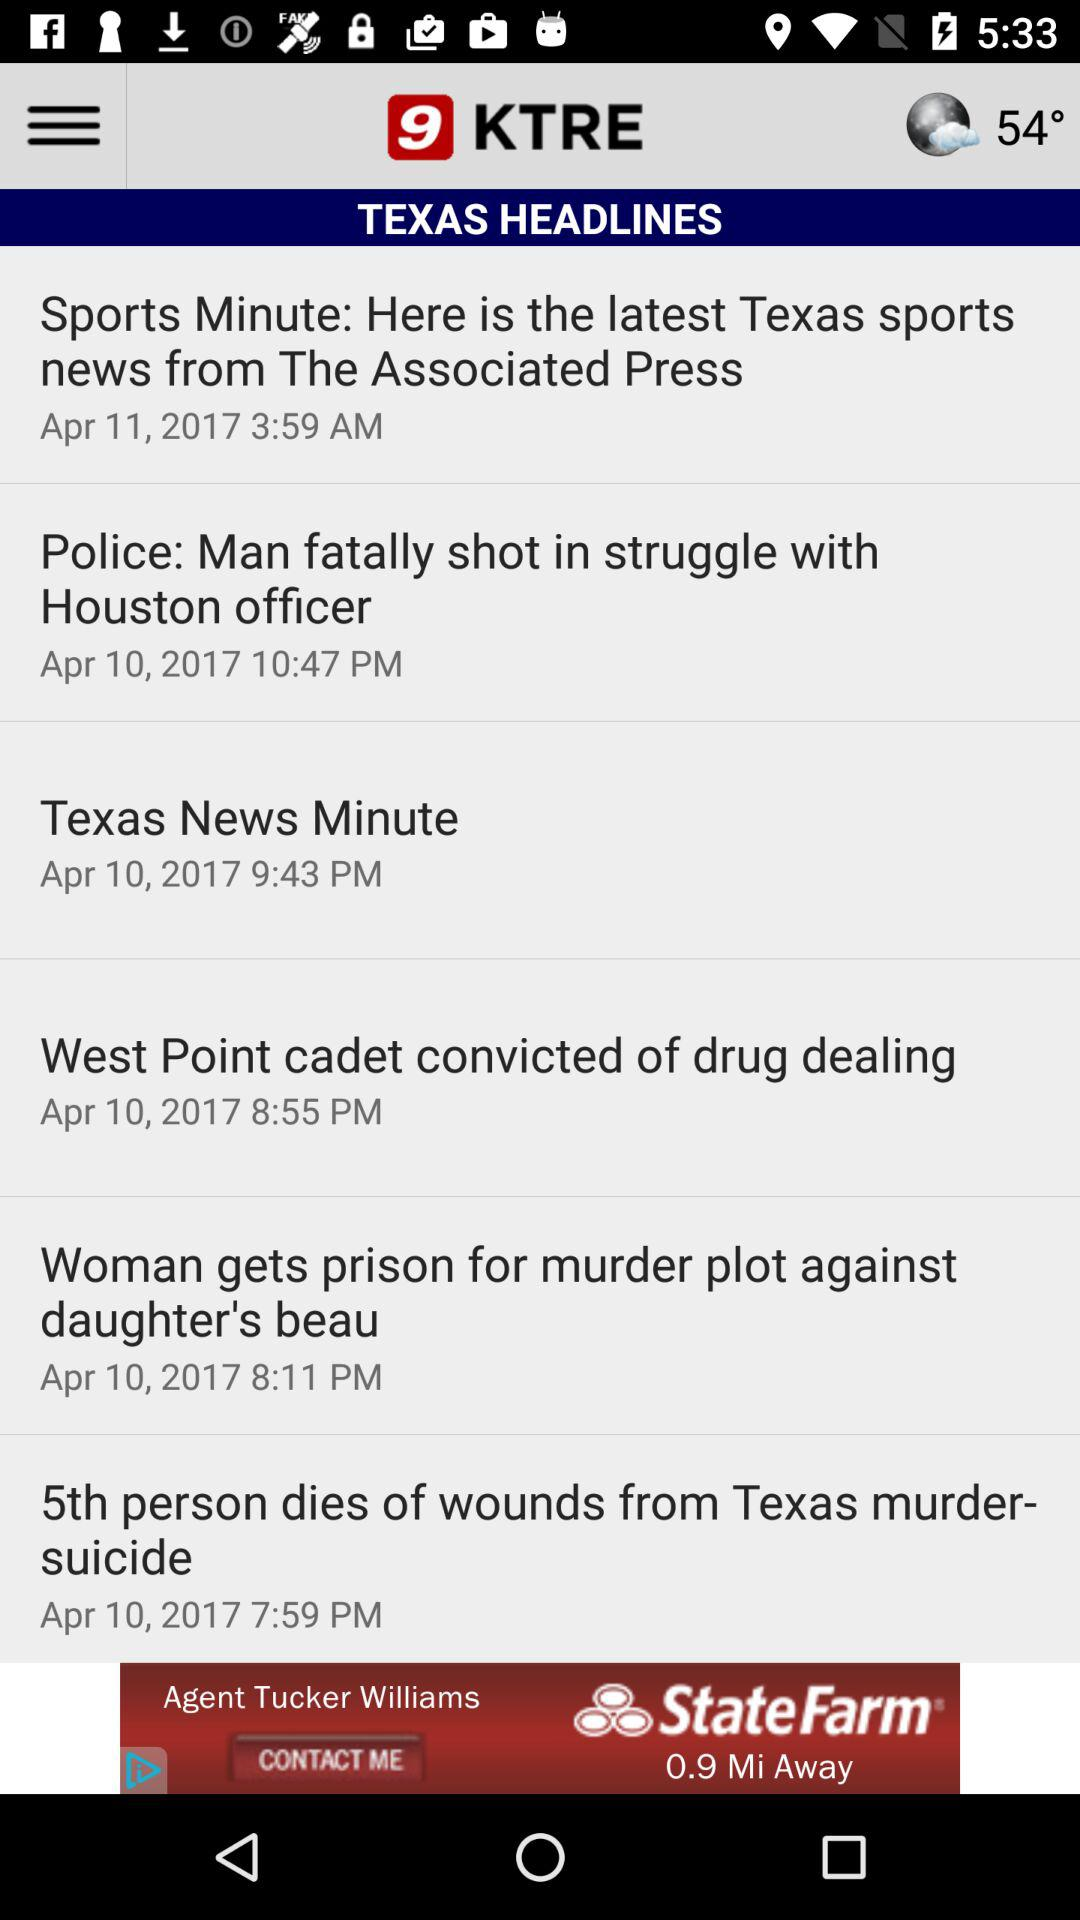What is the posted time of "Sports Minute"? The posted time is 3:59 AM. 